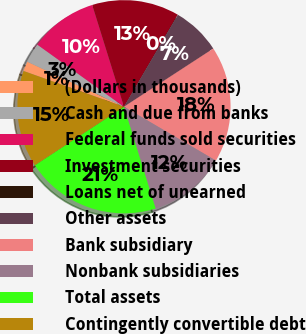<chart> <loc_0><loc_0><loc_500><loc_500><pie_chart><fcel>(Dollars in thousands)<fcel>Cash and due from banks<fcel>Federal funds sold securities<fcel>Investment securities<fcel>Loans net of unearned<fcel>Other assets<fcel>Bank subsidiary<fcel>Nonbank subsidiaries<fcel>Total assets<fcel>Contingently convertible debt<nl><fcel>1.5%<fcel>2.96%<fcel>10.29%<fcel>13.23%<fcel>0.03%<fcel>7.36%<fcel>17.63%<fcel>11.76%<fcel>20.56%<fcel>14.69%<nl></chart> 